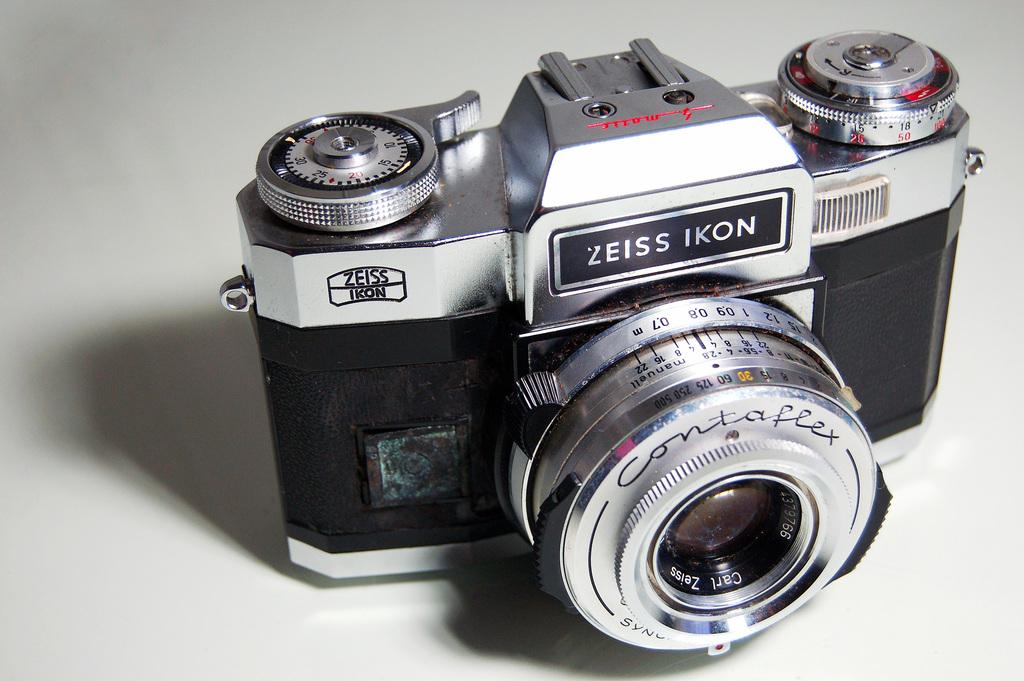What object is present on the floor in the image? There is a camera on the floor in the image. What is the color of the floor in the image? The floor is white in color. How many dust particles can be seen on the camera lens in the image? There is no mention of dust particles on the camera lens in the image, so it cannot be determined from the provided facts. 